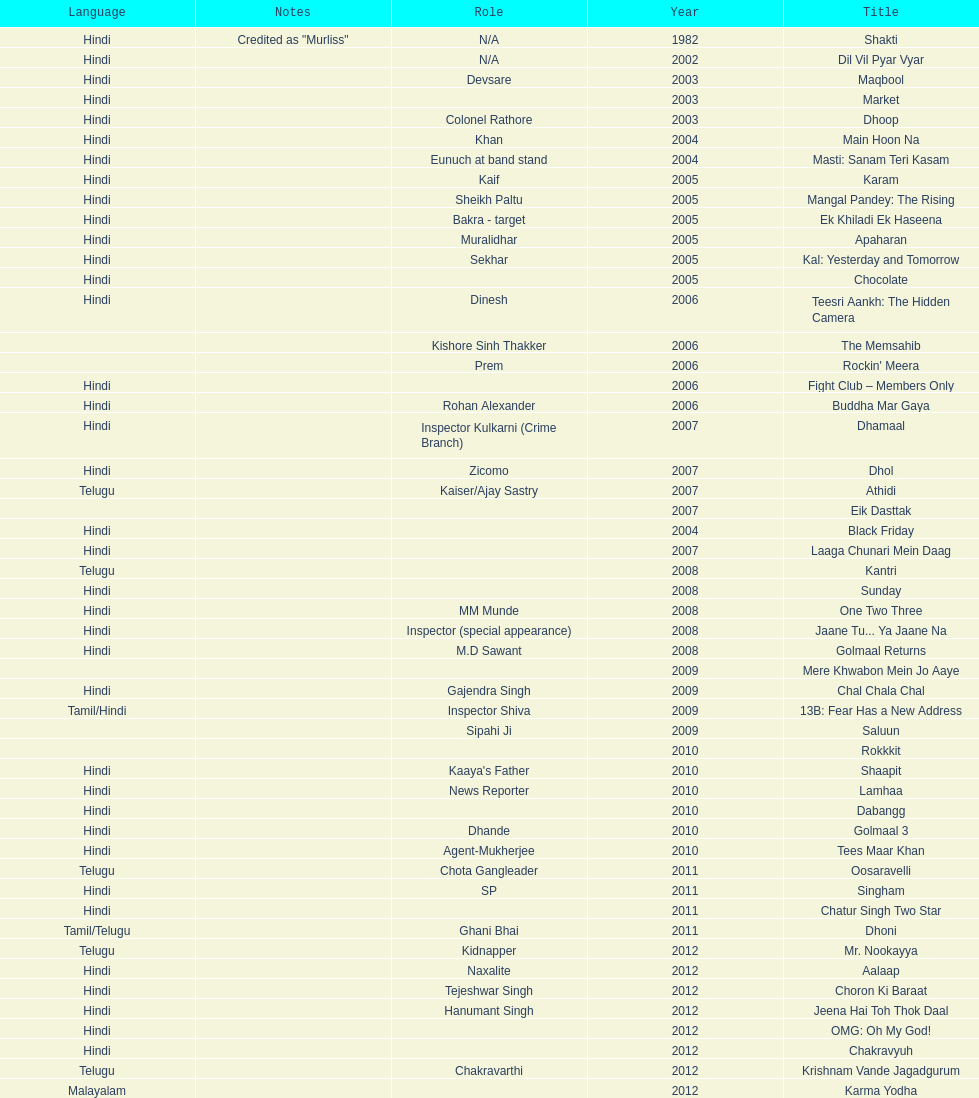What was the last malayalam film this actor starred in? Karma Yodha. 